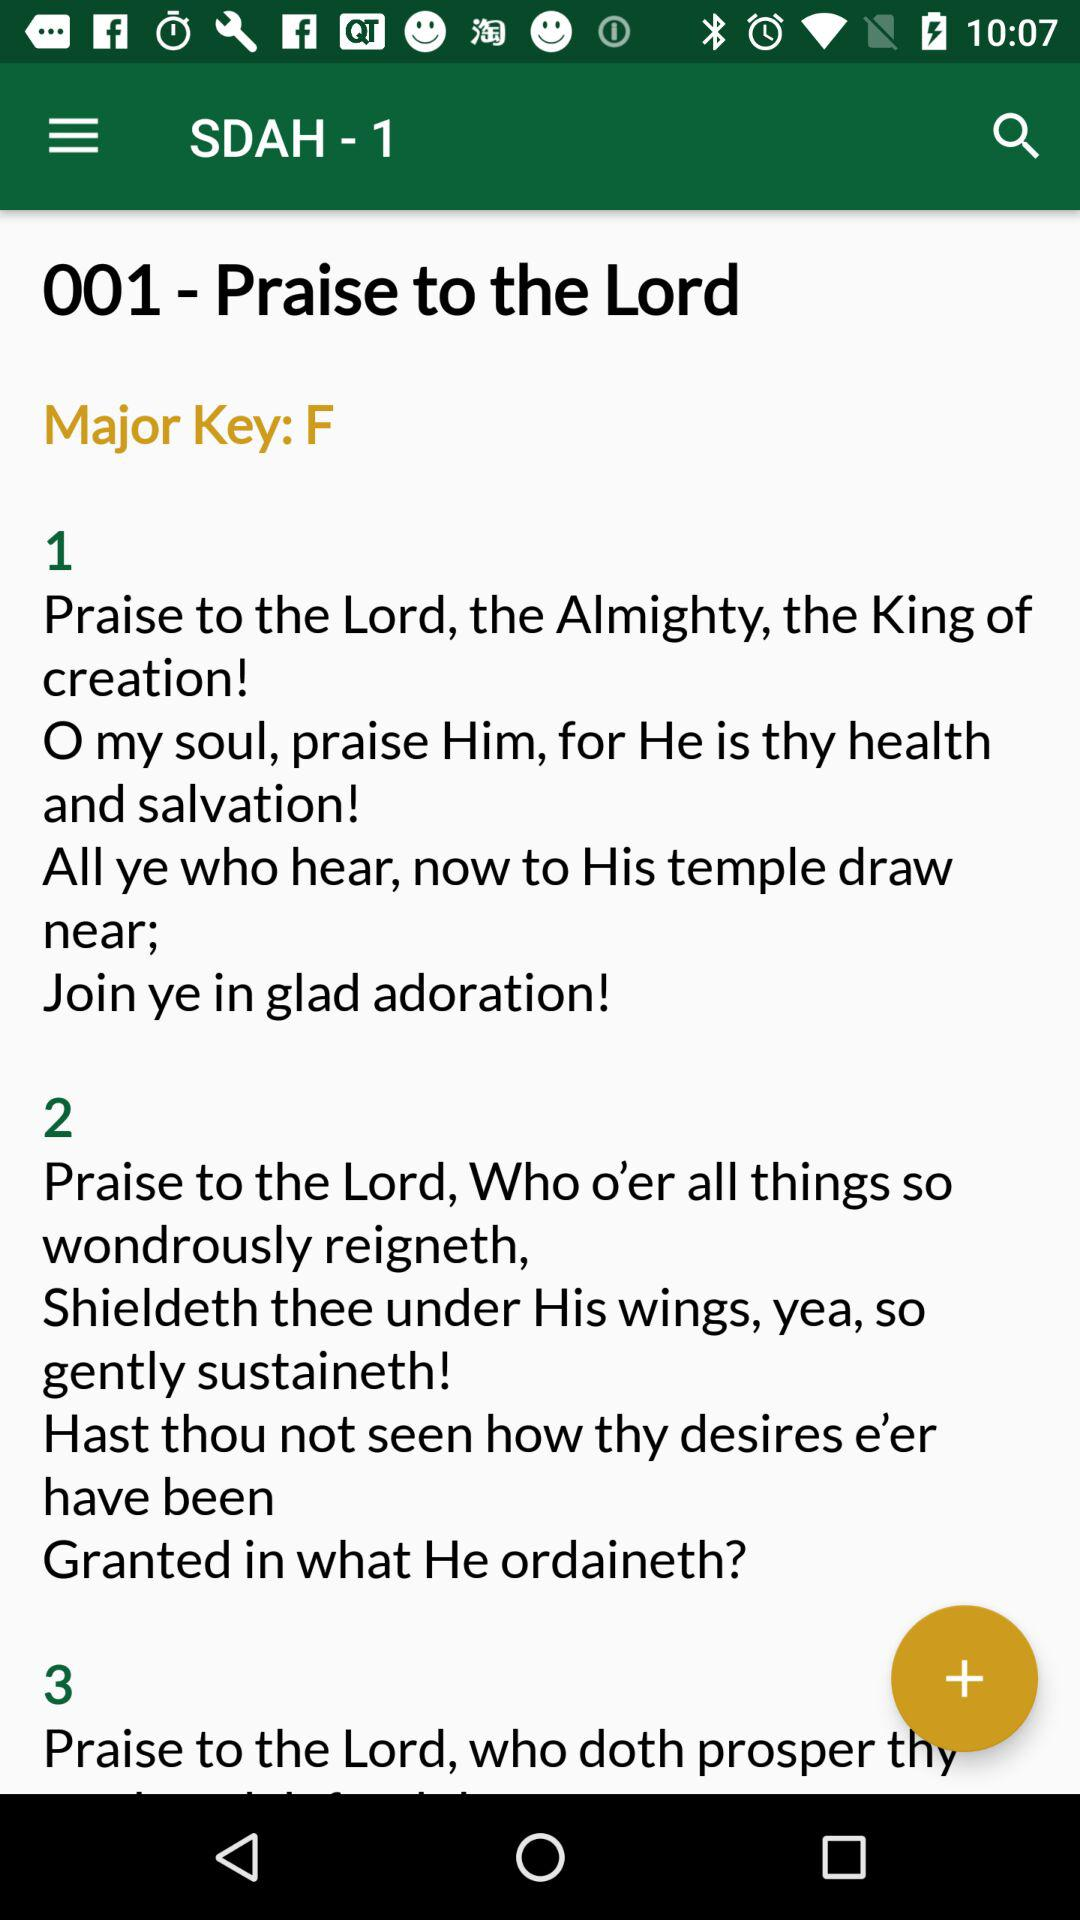How many verses are there in this song?
Answer the question using a single word or phrase. 3 